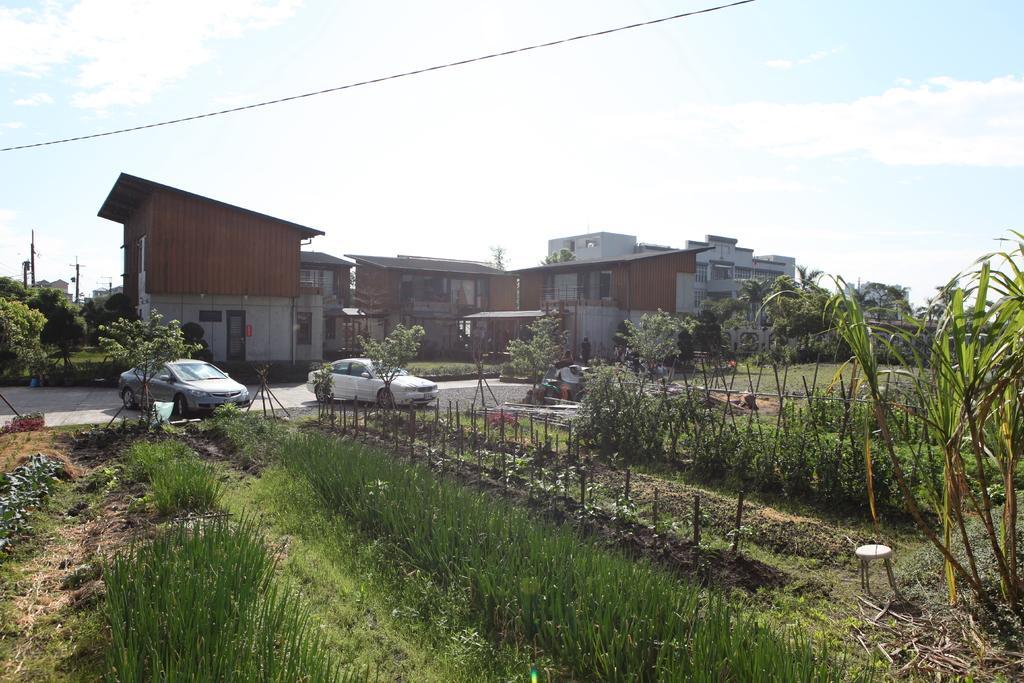How would you summarize this image in a sentence or two? In this picture I can observe two cars parked in the parking lot. In front of the cars I can observe some plants on the ground. In the background there are buildings and some clouds in the sky. 